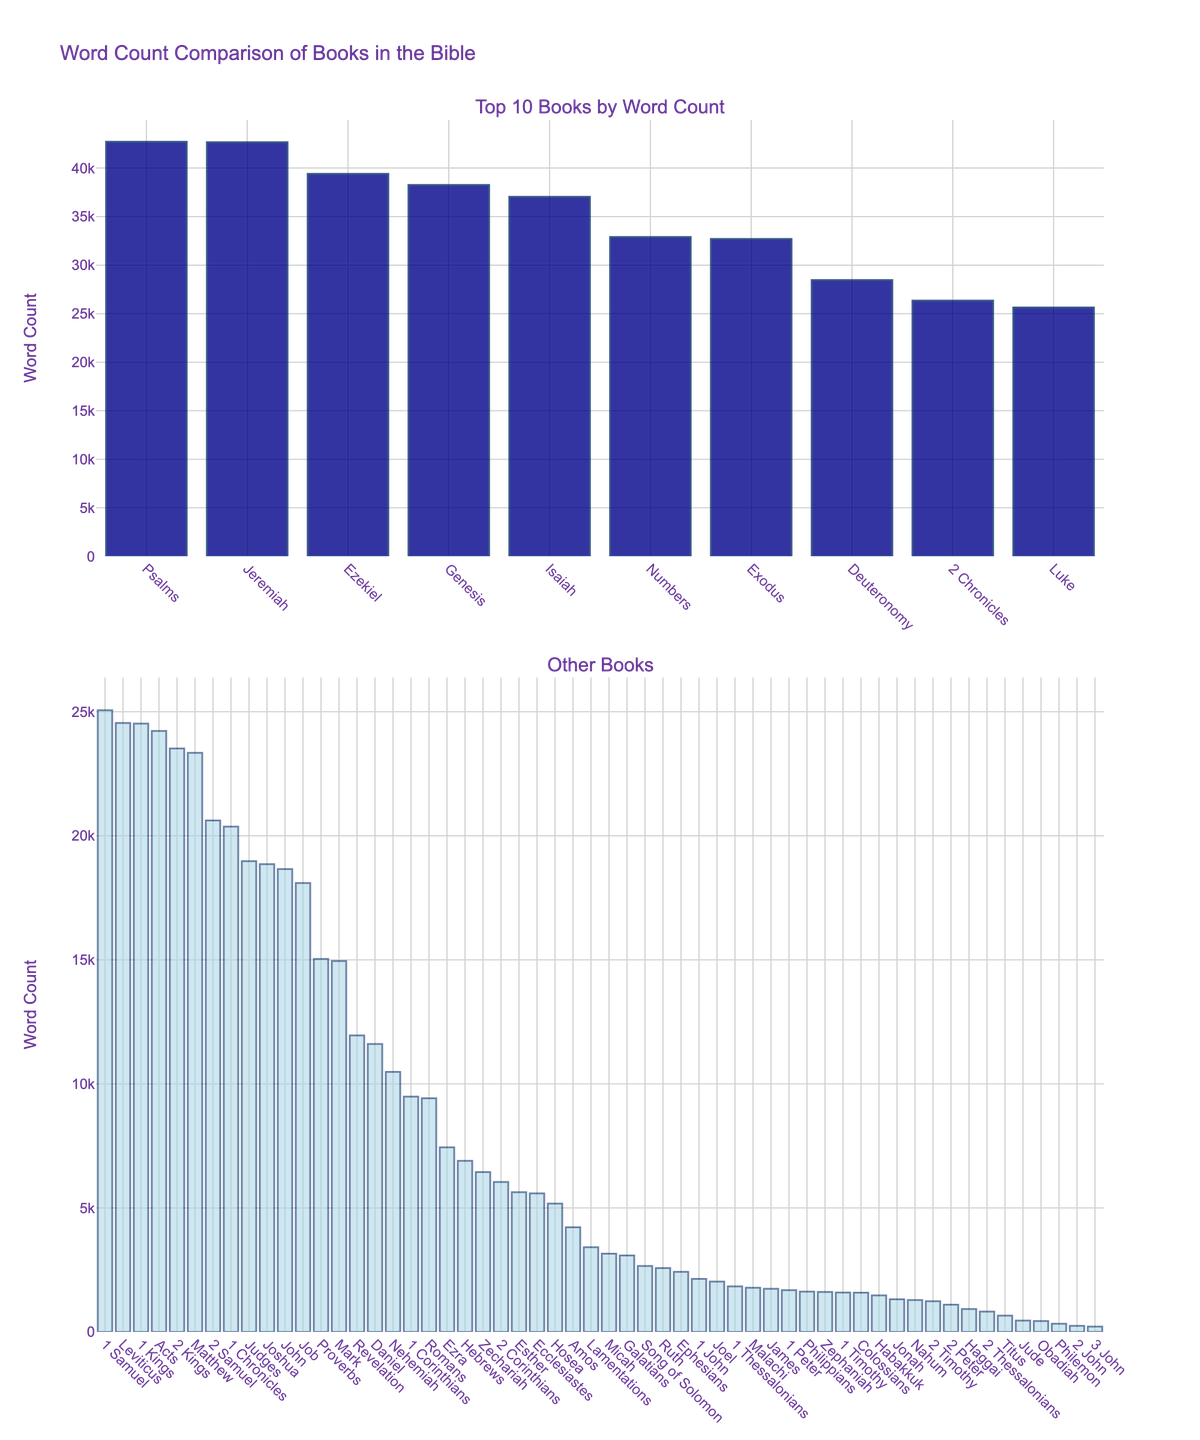Which book has the highest word count? The highest bar in the top subplot represents the book with the highest word count. This bar corresponds to "Psalms."
Answer: Psalms Which book has the lowest word count? The smallest bar in the second subplot represents the book with the lowest word count. This bar corresponds to "3 John."
Answer: 3 John What is the total word count of the top 5 books? To find this, sum the word counts of the top 5 books from the highest: Psalms (42704), Jeremiah (42659), Genesis (38262), Ezekiel (39407), and Isaiah (37044). The total is 42704 + 42659 + 38262 + 39407 + 37044.
Answer: 200076 Is the word count of Exodus greater than that of Deuteronomy? Compare the height of the bars for "Exodus" and "Deuteronomy." The bar for "Exodus" is taller, indicating a higher word count than "Deuteronomy."
Answer: Yes Which book has a word count closest to 10,000? Look for the bar whose height is closest to the 10,000 mark. The "Nehemiah" bar closely matches this value.
Answer: Nehemiah What is the difference in word count between John and Acts? John has a word count of 18658, and Acts has 24229. Subtract the word count of John from that of Acts: 24229 - 18658.
Answer: 5571 How many books have a word count greater than 20,000? Count the bars in both subplots that exceed the 20,000 mark. They are for Psalms, Jeremiah, Genesis, Ezekiel, Isaiah, Job, Exodus, Numbers, Deuteronomy, 1 Samuel, 2 Samuel, 1 Kings, 2 Kings, 1 Chronicles, 2 Chronicles, and Luke, totaling 16 books.
Answer: 16 Which book with a word count between 5,000 and 10,000 has the highest count? Among the books listed in this range, Hebrews has the highest word count.
Answer: Hebrews 